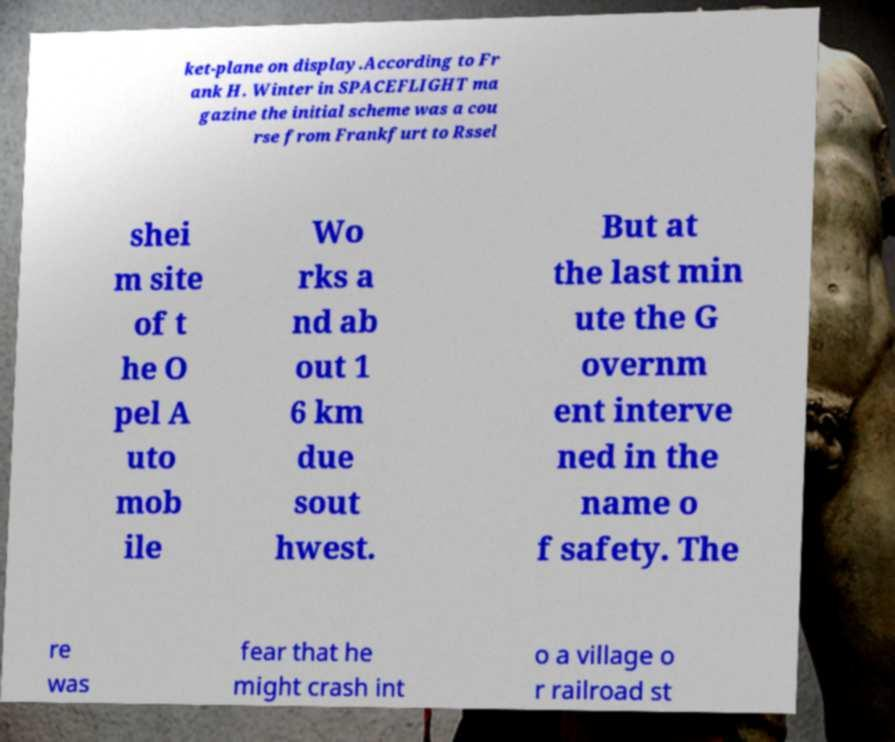What messages or text are displayed in this image? I need them in a readable, typed format. ket-plane on display.According to Fr ank H. Winter in SPACEFLIGHT ma gazine the initial scheme was a cou rse from Frankfurt to Rssel shei m site of t he O pel A uto mob ile Wo rks a nd ab out 1 6 km due sout hwest. But at the last min ute the G overnm ent interve ned in the name o f safety. The re was fear that he might crash int o a village o r railroad st 